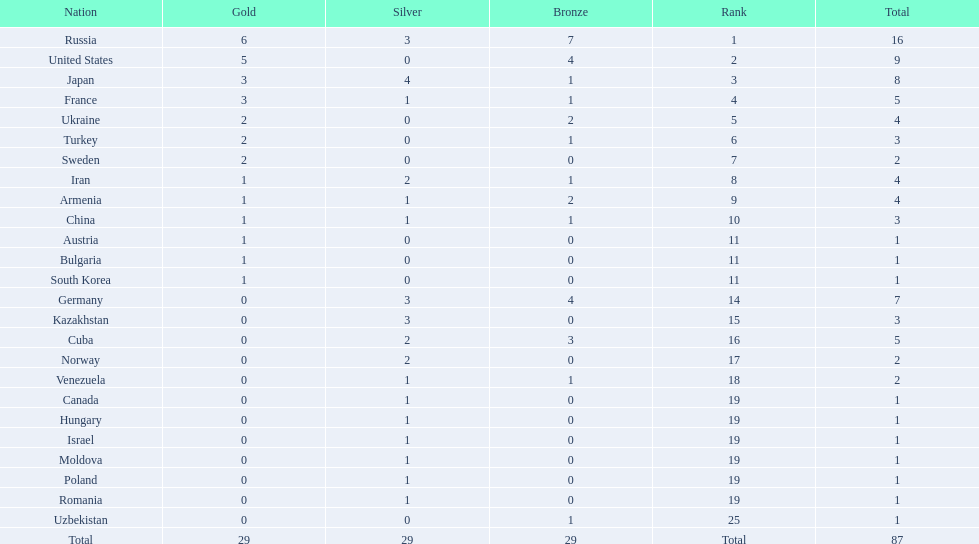Who won more gold medals than the united states? Russia. Parse the table in full. {'header': ['Nation', 'Gold', 'Silver', 'Bronze', 'Rank', 'Total'], 'rows': [['Russia', '6', '3', '7', '1', '16'], ['United States', '5', '0', '4', '2', '9'], ['Japan', '3', '4', '1', '3', '8'], ['France', '3', '1', '1', '4', '5'], ['Ukraine', '2', '0', '2', '5', '4'], ['Turkey', '2', '0', '1', '6', '3'], ['Sweden', '2', '0', '0', '7', '2'], ['Iran', '1', '2', '1', '8', '4'], ['Armenia', '1', '1', '2', '9', '4'], ['China', '1', '1', '1', '10', '3'], ['Austria', '1', '0', '0', '11', '1'], ['Bulgaria', '1', '0', '0', '11', '1'], ['South Korea', '1', '0', '0', '11', '1'], ['Germany', '0', '3', '4', '14', '7'], ['Kazakhstan', '0', '3', '0', '15', '3'], ['Cuba', '0', '2', '3', '16', '5'], ['Norway', '0', '2', '0', '17', '2'], ['Venezuela', '0', '1', '1', '18', '2'], ['Canada', '0', '1', '0', '19', '1'], ['Hungary', '0', '1', '0', '19', '1'], ['Israel', '0', '1', '0', '19', '1'], ['Moldova', '0', '1', '0', '19', '1'], ['Poland', '0', '1', '0', '19', '1'], ['Romania', '0', '1', '0', '19', '1'], ['Uzbekistan', '0', '0', '1', '25', '1'], ['Total', '29', '29', '29', 'Total', '87']]} 